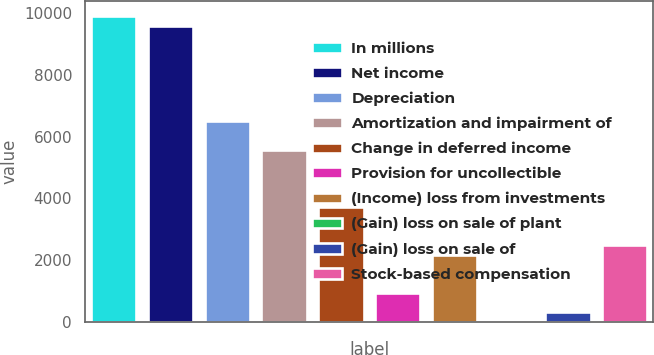Convert chart to OTSL. <chart><loc_0><loc_0><loc_500><loc_500><bar_chart><fcel>In millions<fcel>Net income<fcel>Depreciation<fcel>Amortization and impairment of<fcel>Change in deferred income<fcel>Provision for uncollectible<fcel>(Income) loss from investments<fcel>(Gain) loss on sale of plant<fcel>(Gain) loss on sale of<fcel>Stock-based compensation<nl><fcel>9898.6<fcel>9589.3<fcel>6496.3<fcel>5568.4<fcel>3712.6<fcel>928.9<fcel>2166.1<fcel>1<fcel>310.3<fcel>2475.4<nl></chart> 